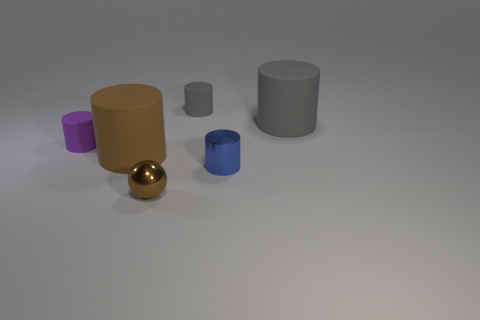The matte thing on the right side of the gray matte thing to the left of the big thing behind the large brown cylinder is what color?
Your answer should be very brief. Gray. Is the small purple object the same shape as the large brown thing?
Your response must be concise. Yes. Are there the same number of tiny purple cylinders to the left of the purple object and tiny green rubber objects?
Your response must be concise. Yes. What number of other objects are the same material as the purple cylinder?
Your response must be concise. 3. Is the size of the cylinder in front of the brown cylinder the same as the gray thing right of the small gray matte cylinder?
Provide a short and direct response. No. How many objects are either large objects that are behind the brown rubber cylinder or objects to the right of the shiny cylinder?
Your answer should be compact. 1. Is there anything else that is the same shape as the small blue object?
Offer a very short reply. Yes. There is a rubber thing that is on the right side of the tiny gray matte thing; does it have the same color as the tiny rubber cylinder behind the big gray cylinder?
Provide a succinct answer. Yes. How many metallic things are small brown balls or big cylinders?
Offer a very short reply. 1. There is a tiny brown metal thing in front of the gray object behind the big gray matte cylinder; what is its shape?
Your response must be concise. Sphere. 